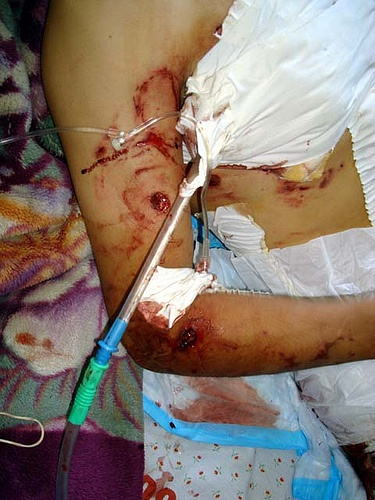Describe the objects in this image and their specific colors. I can see people in black, lightgray, brown, gray, and tan tones and bed in black, gray, maroon, and darkgray tones in this image. 